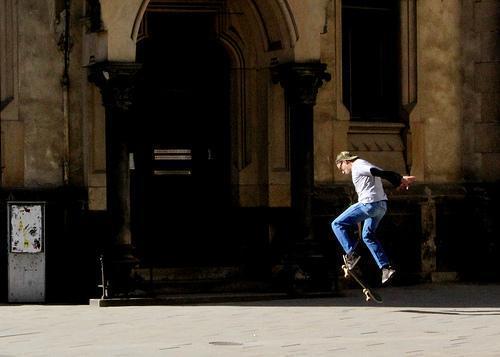How many shoes is he wearing?
Give a very brief answer. 2. How many doors are visible?
Give a very brief answer. 1. 